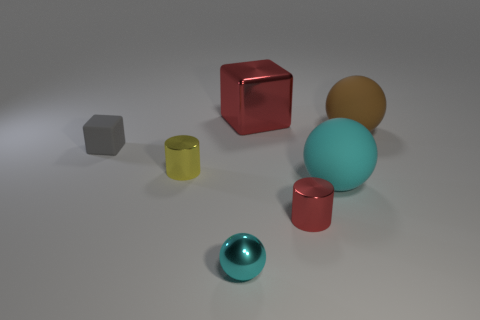Add 1 small metallic spheres. How many objects exist? 8 Subtract all balls. How many objects are left? 4 Subtract 0 gray cylinders. How many objects are left? 7 Subtract all cyan matte objects. Subtract all tiny balls. How many objects are left? 5 Add 2 tiny cyan metallic balls. How many tiny cyan metallic balls are left? 3 Add 6 tiny spheres. How many tiny spheres exist? 7 